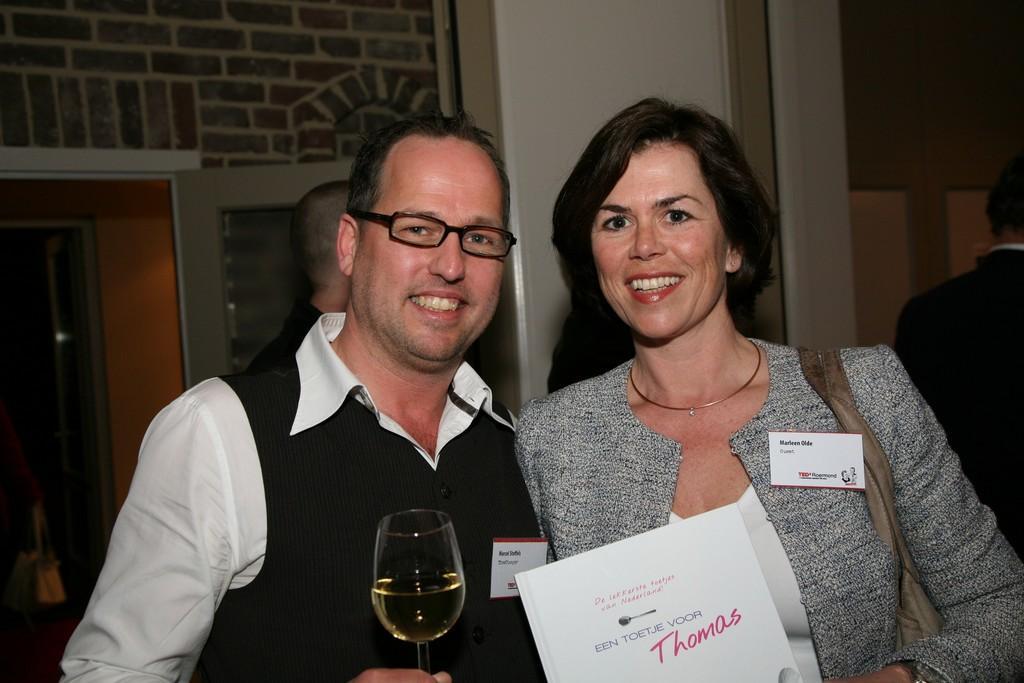How would you summarize this image in a sentence or two? In this picture there is a couple standing in the front, holding the wine glass and giving a pose to the camera. Behind there is a arch wall and door. 